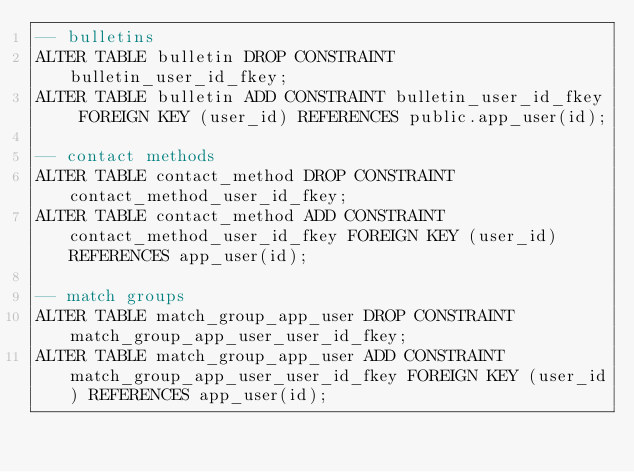Convert code to text. <code><loc_0><loc_0><loc_500><loc_500><_SQL_>-- bulletins
ALTER TABLE bulletin DROP CONSTRAINT bulletin_user_id_fkey;
ALTER TABLE bulletin ADD CONSTRAINT bulletin_user_id_fkey FOREIGN KEY (user_id) REFERENCES public.app_user(id);

-- contact methods
ALTER TABLE contact_method DROP CONSTRAINT contact_method_user_id_fkey;
ALTER TABLE contact_method ADD CONSTRAINT contact_method_user_id_fkey FOREIGN KEY (user_id) REFERENCES app_user(id);

-- match groups
ALTER TABLE match_group_app_user DROP CONSTRAINT match_group_app_user_user_id_fkey;
ALTER TABLE match_group_app_user ADD CONSTRAINT match_group_app_user_user_id_fkey FOREIGN KEY (user_id) REFERENCES app_user(id);</code> 